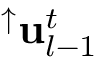<formula> <loc_0><loc_0><loc_500><loc_500>^ { \uparrow } u _ { l - 1 } ^ { t }</formula> 